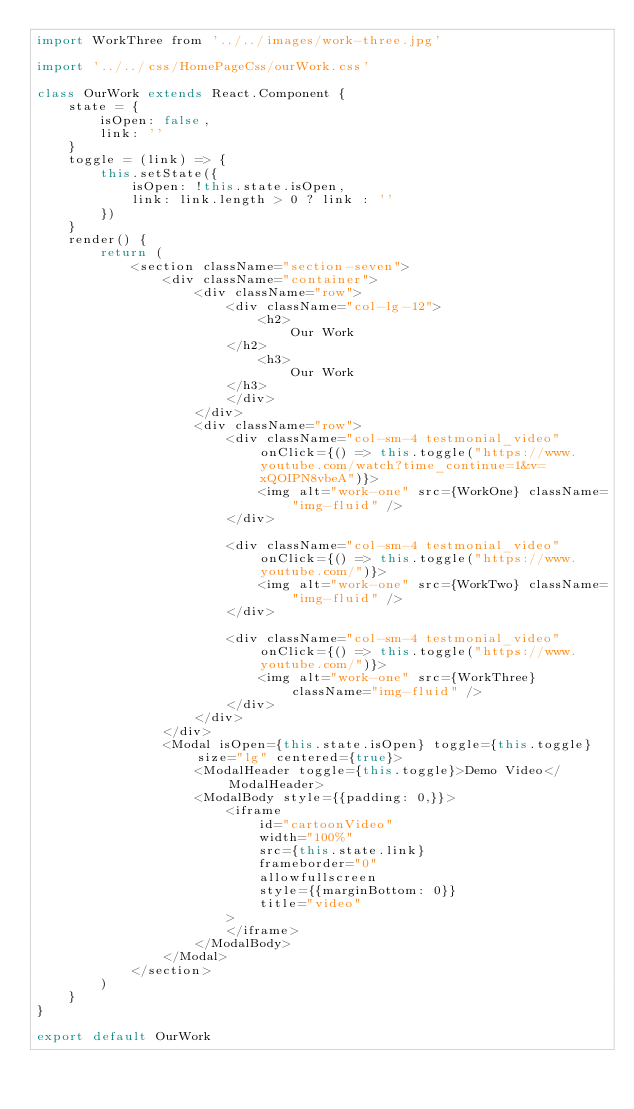<code> <loc_0><loc_0><loc_500><loc_500><_JavaScript_>import WorkThree from '../../images/work-three.jpg'

import '../../css/HomePageCss/ourWork.css'

class OurWork extends React.Component {
    state = {
        isOpen: false,
        link: ''
    }
    toggle = (link) => {
        this.setState({
            isOpen: !this.state.isOpen,
            link: link.length > 0 ? link : ''
        })
    }
    render() {
        return (
            <section className="section-seven">
                <div className="container">
                    <div className="row">
                        <div className="col-lg-12">
                            <h2>
                                Our Work
                        </h2>
                            <h3>
                                Our Work
                        </h3>
                        </div>
                    </div>
                    <div className="row">
                        <div className="col-sm-4 testmonial_video" onClick={() => this.toggle("https://www.youtube.com/watch?time_continue=1&v=xQOIPN8vbeA")}>
                            <img alt="work-one" src={WorkOne} className="img-fluid" />
                        </div>

                        <div className="col-sm-4 testmonial_video" onClick={() => this.toggle("https://www.youtube.com/")}>
                            <img alt="work-one" src={WorkTwo} className="img-fluid" />
                        </div>

                        <div className="col-sm-4 testmonial_video" onClick={() => this.toggle("https://www.youtube.com/")}>
                            <img alt="work-one" src={WorkThree} className="img-fluid" />
                        </div>
                    </div>
                </div>
                <Modal isOpen={this.state.isOpen} toggle={this.toggle} size="lg" centered={true}>
                    <ModalHeader toggle={this.toggle}>Demo Video</ModalHeader>
                    <ModalBody style={{padding: 0,}}>
                        <iframe
                            id="cartoonVideo"
                            width="100%"
                            src={this.state.link}
                            frameborder="0"
                            allowfullscreen
                            style={{marginBottom: 0}}
                            title="video"
                        >
                        </iframe>
                    </ModalBody>
                </Modal>
            </section>
        )
    }
}

export default OurWork
</code> 